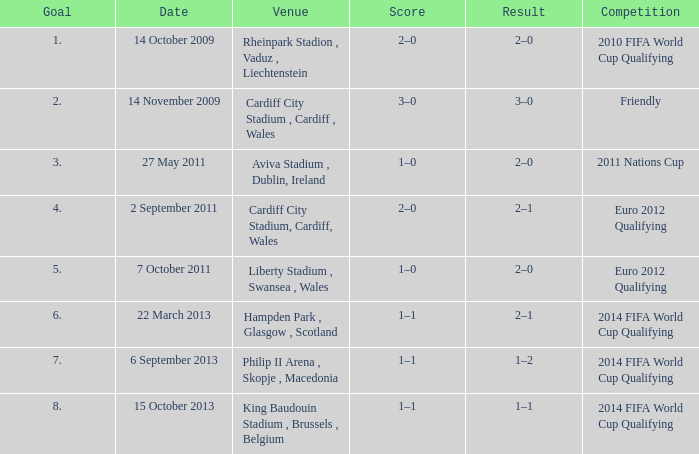What is the Venue for Goal number 1? Rheinpark Stadion , Vaduz , Liechtenstein. 